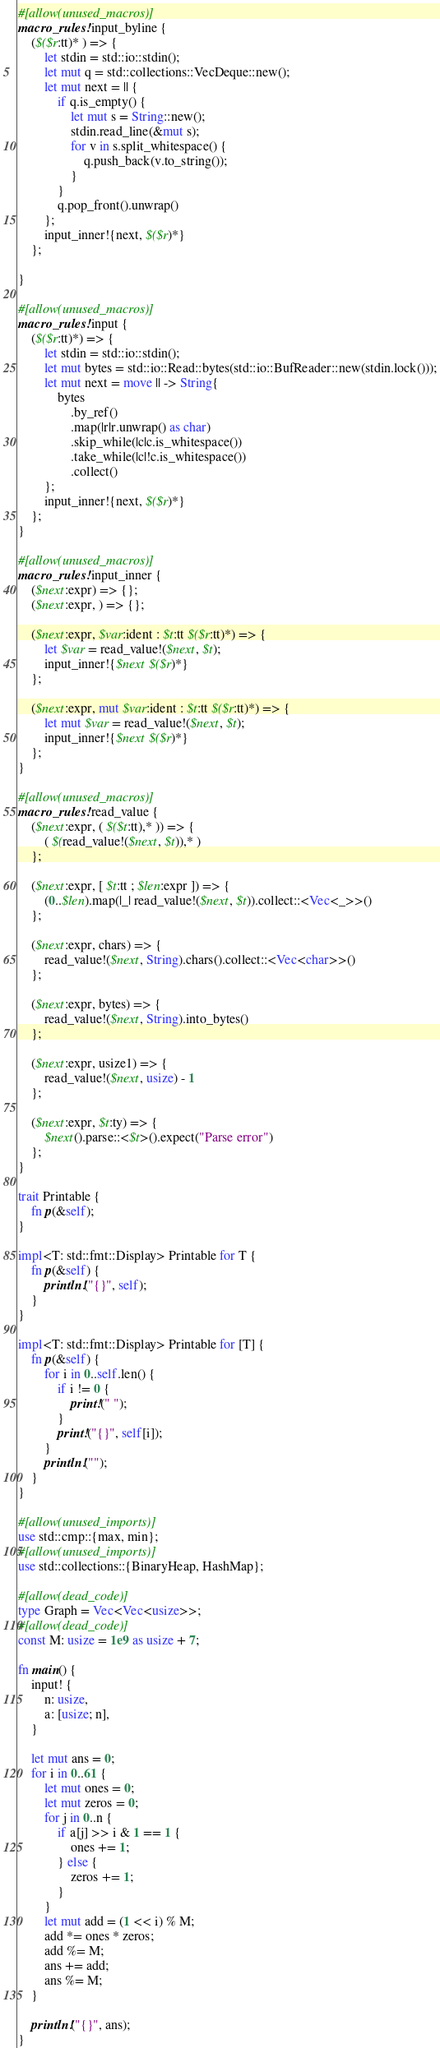<code> <loc_0><loc_0><loc_500><loc_500><_Rust_>#[allow(unused_macros)]
macro_rules! input_byline {
    ($($r:tt)* ) => {
        let stdin = std::io::stdin();
        let mut q = std::collections::VecDeque::new();
        let mut next = || {
            if q.is_empty() {
                let mut s = String::new();
                stdin.read_line(&mut s);
                for v in s.split_whitespace() {
                    q.push_back(v.to_string());
                }
            }
            q.pop_front().unwrap()
        };
        input_inner!{next, $($r)*}
    };

}

#[allow(unused_macros)]
macro_rules! input {
    ($($r:tt)*) => {
        let stdin = std::io::stdin();
        let mut bytes = std::io::Read::bytes(std::io::BufReader::new(stdin.lock()));
        let mut next = move || -> String{
            bytes
                .by_ref()
                .map(|r|r.unwrap() as char)
                .skip_while(|c|c.is_whitespace())
                .take_while(|c|!c.is_whitespace())
                .collect()
        };
        input_inner!{next, $($r)*}
    };
}

#[allow(unused_macros)]
macro_rules! input_inner {
    ($next:expr) => {};
    ($next:expr, ) => {};

    ($next:expr, $var:ident : $t:tt $($r:tt)*) => {
        let $var = read_value!($next, $t);
        input_inner!{$next $($r)*}
    };

    ($next:expr, mut $var:ident : $t:tt $($r:tt)*) => {
        let mut $var = read_value!($next, $t);
        input_inner!{$next $($r)*}
    };
}

#[allow(unused_macros)]
macro_rules! read_value {
    ($next:expr, ( $($t:tt),* )) => {
        ( $(read_value!($next, $t)),* )
    };

    ($next:expr, [ $t:tt ; $len:expr ]) => {
        (0..$len).map(|_| read_value!($next, $t)).collect::<Vec<_>>()
    };

    ($next:expr, chars) => {
        read_value!($next, String).chars().collect::<Vec<char>>()
    };

    ($next:expr, bytes) => {
        read_value!($next, String).into_bytes()
    };

    ($next:expr, usize1) => {
        read_value!($next, usize) - 1
    };

    ($next:expr, $t:ty) => {
        $next().parse::<$t>().expect("Parse error")
    };
}

trait Printable {
    fn p(&self);
}

impl<T: std::fmt::Display> Printable for T {
    fn p(&self) {
        println!("{}", self);
    }
}

impl<T: std::fmt::Display> Printable for [T] {
    fn p(&self) {
        for i in 0..self.len() {
            if i != 0 {
                print!(" ");
            }
            print!("{}", self[i]);
        }
        println!("");
    }
}

#[allow(unused_imports)]
use std::cmp::{max, min};
#[allow(unused_imports)]
use std::collections::{BinaryHeap, HashMap};

#[allow(dead_code)]
type Graph = Vec<Vec<usize>>;
#[allow(dead_code)]
const M: usize = 1e9 as usize + 7;

fn main() {
    input! {
        n: usize,
        a: [usize; n],
    }

    let mut ans = 0;
    for i in 0..61 {
        let mut ones = 0;
        let mut zeros = 0;
        for j in 0..n {
            if a[j] >> i & 1 == 1 {
                ones += 1;
            } else {
                zeros += 1;
            }
        }
        let mut add = (1 << i) % M;
        add *= ones * zeros;
        add %= M;
        ans += add;
        ans %= M;
    }

    println!("{}", ans);
}
</code> 